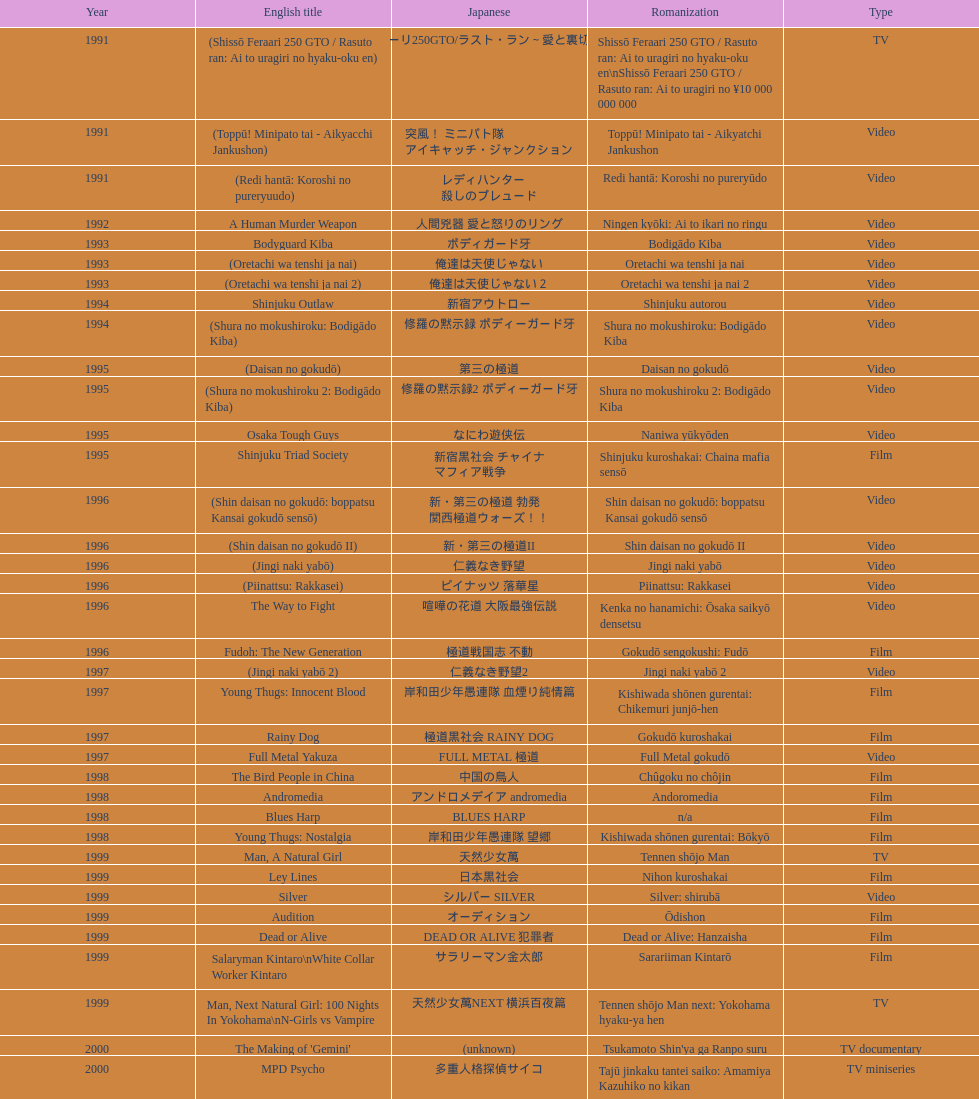State a cinema that was launched earlier than 199 Shinjuku Triad Society. Can you give me this table as a dict? {'header': ['Year', 'English title', 'Japanese', 'Romanization', 'Type'], 'rows': [['1991', '(Shissō Feraari 250 GTO / Rasuto ran: Ai to uragiri no hyaku-oku en)', '疾走フェラーリ250GTO/ラスト・ラン～愛と裏切りの百億円', 'Shissō Feraari 250 GTO / Rasuto ran: Ai to uragiri no hyaku-oku en\\nShissō Feraari 250 GTO / Rasuto ran: Ai to uragiri no ¥10 000 000 000', 'TV'], ['1991', '(Toppū! Minipato tai - Aikyacchi Jankushon)', '突風！ ミニパト隊 アイキャッチ・ジャンクション', 'Toppū! Minipato tai - Aikyatchi Jankushon', 'Video'], ['1991', '(Redi hantā: Koroshi no pureryuudo)', 'レディハンター 殺しのプレュード', 'Redi hantā: Koroshi no pureryūdo', 'Video'], ['1992', 'A Human Murder Weapon', '人間兇器 愛と怒りのリング', 'Ningen kyōki: Ai to ikari no ringu', 'Video'], ['1993', 'Bodyguard Kiba', 'ボディガード牙', 'Bodigādo Kiba', 'Video'], ['1993', '(Oretachi wa tenshi ja nai)', '俺達は天使じゃない', 'Oretachi wa tenshi ja nai', 'Video'], ['1993', '(Oretachi wa tenshi ja nai 2)', '俺達は天使じゃない２', 'Oretachi wa tenshi ja nai 2', 'Video'], ['1994', 'Shinjuku Outlaw', '新宿アウトロー', 'Shinjuku autorou', 'Video'], ['1994', '(Shura no mokushiroku: Bodigādo Kiba)', '修羅の黙示録 ボディーガード牙', 'Shura no mokushiroku: Bodigādo Kiba', 'Video'], ['1995', '(Daisan no gokudō)', '第三の極道', 'Daisan no gokudō', 'Video'], ['1995', '(Shura no mokushiroku 2: Bodigādo Kiba)', '修羅の黙示録2 ボディーガード牙', 'Shura no mokushiroku 2: Bodigādo Kiba', 'Video'], ['1995', 'Osaka Tough Guys', 'なにわ遊侠伝', 'Naniwa yūkyōden', 'Video'], ['1995', 'Shinjuku Triad Society', '新宿黒社会 チャイナ マフィア戦争', 'Shinjuku kuroshakai: Chaina mafia sensō', 'Film'], ['1996', '(Shin daisan no gokudō: boppatsu Kansai gokudō sensō)', '新・第三の極道 勃発 関西極道ウォーズ！！', 'Shin daisan no gokudō: boppatsu Kansai gokudō sensō', 'Video'], ['1996', '(Shin daisan no gokudō II)', '新・第三の極道II', 'Shin daisan no gokudō II', 'Video'], ['1996', '(Jingi naki yabō)', '仁義なき野望', 'Jingi naki yabō', 'Video'], ['1996', '(Piinattsu: Rakkasei)', 'ピイナッツ 落華星', 'Piinattsu: Rakkasei', 'Video'], ['1996', 'The Way to Fight', '喧嘩の花道 大阪最強伝説', 'Kenka no hanamichi: Ōsaka saikyō densetsu', 'Video'], ['1996', 'Fudoh: The New Generation', '極道戦国志 不動', 'Gokudō sengokushi: Fudō', 'Film'], ['1997', '(Jingi naki yabō 2)', '仁義なき野望2', 'Jingi naki yabō 2', 'Video'], ['1997', 'Young Thugs: Innocent Blood', '岸和田少年愚連隊 血煙り純情篇', 'Kishiwada shōnen gurentai: Chikemuri junjō-hen', 'Film'], ['1997', 'Rainy Dog', '極道黒社会 RAINY DOG', 'Gokudō kuroshakai', 'Film'], ['1997', 'Full Metal Yakuza', 'FULL METAL 極道', 'Full Metal gokudō', 'Video'], ['1998', 'The Bird People in China', '中国の鳥人', 'Chûgoku no chôjin', 'Film'], ['1998', 'Andromedia', 'アンドロメデイア andromedia', 'Andoromedia', 'Film'], ['1998', 'Blues Harp', 'BLUES HARP', 'n/a', 'Film'], ['1998', 'Young Thugs: Nostalgia', '岸和田少年愚連隊 望郷', 'Kishiwada shōnen gurentai: Bōkyō', 'Film'], ['1999', 'Man, A Natural Girl', '天然少女萬', 'Tennen shōjo Man', 'TV'], ['1999', 'Ley Lines', '日本黒社会', 'Nihon kuroshakai', 'Film'], ['1999', 'Silver', 'シルバー SILVER', 'Silver: shirubā', 'Video'], ['1999', 'Audition', 'オーディション', 'Ōdishon', 'Film'], ['1999', 'Dead or Alive', 'DEAD OR ALIVE 犯罪者', 'Dead or Alive: Hanzaisha', 'Film'], ['1999', 'Salaryman Kintaro\\nWhite Collar Worker Kintaro', 'サラリーマン金太郎', 'Sarariiman Kintarō', 'Film'], ['1999', 'Man, Next Natural Girl: 100 Nights In Yokohama\\nN-Girls vs Vampire', '天然少女萬NEXT 横浜百夜篇', 'Tennen shōjo Man next: Yokohama hyaku-ya hen', 'TV'], ['2000', "The Making of 'Gemini'", '(unknown)', "Tsukamoto Shin'ya ga Ranpo suru", 'TV documentary'], ['2000', 'MPD Psycho', '多重人格探偵サイコ', 'Tajū jinkaku tantei saiko: Amamiya Kazuhiko no kikan', 'TV miniseries'], ['2000', 'The City of Lost Souls\\nThe City of Strangers\\nThe Hazard City', '漂流街 THE HAZARD CITY', 'Hyōryū-gai', 'Film'], ['2000', 'The Guys from Paradise', '天国から来た男たち', 'Tengoku kara kita otoko-tachi', 'Film'], ['2000', 'Dead or Alive 2: Birds\\nDead or Alive 2: Runaway', 'DEAD OR ALIVE 2 逃亡者', 'Dead or Alive 2: Tōbōsha', 'Film'], ['2001', '(Kikuchi-jō monogatari: sakimori-tachi no uta)', '鞠智城物語 防人たちの唄', 'Kikuchi-jō monogatari: sakimori-tachi no uta', 'Film'], ['2001', '(Zuiketsu gensō: Tonkararin yume densetsu)', '隧穴幻想 トンカラリン夢伝説', 'Zuiketsu gensō: Tonkararin yume densetsu', 'Film'], ['2001', 'Family', 'FAMILY', 'n/a', 'Film'], ['2001', 'Visitor Q', 'ビジターQ', 'Bijitā Q', 'Video'], ['2001', 'Ichi the Killer', '殺し屋1', 'Koroshiya 1', 'Film'], ['2001', 'Agitator', '荒ぶる魂たち', 'Araburu tamashii-tachi', 'Film'], ['2001', 'The Happiness of the Katakuris', 'カタクリ家の幸福', 'Katakuri-ke no kōfuku', 'Film'], ['2002', 'Dead or Alive: Final', 'DEAD OR ALIVE FINAL', 'n/a', 'Film'], ['2002', '(Onna kunishū ikki)', 'おんな 国衆一揆', 'Onna kunishū ikki', '(unknown)'], ['2002', 'Sabu', 'SABU さぶ', 'Sabu', 'TV'], ['2002', 'Graveyard of Honor', '新・仁義の墓場', 'Shin jingi no hakaba', 'Film'], ['2002', 'Shangri-La', '金融破滅ニッポン 桃源郷の人々', "Kin'yū hametsu Nippon: Tōgenkyō no hito-bito", 'Film'], ['2002', 'Pandōra', 'パンドーラ', 'Pandōra', 'Music video'], ['2002', 'Deadly Outlaw: Rekka\\nViolent Fire', '実録・安藤昇侠道（アウトロー）伝 烈火', 'Jitsuroku Andō Noboru kyōdō-den: Rekka', 'Film'], ['2002', 'Pāto-taimu tantei', 'パートタイム探偵', 'Pāto-taimu tantei', 'TV series'], ['2003', 'The Man in White', '許されざる者', 'Yurusarezaru mono', 'Film'], ['2003', 'Gozu', '極道恐怖大劇場 牛頭 GOZU', 'Gokudō kyōfu dai-gekijō: Gozu', 'Film'], ['2003', 'Yakuza Demon', '鬼哭 kikoku', 'Kikoku', 'Video'], ['2003', 'Kōshōnin', '交渉人', 'Kōshōnin', 'TV'], ['2003', "One Missed Call\\nYou've Got a Call", '着信アリ', 'Chakushin Ari', 'Film'], ['2004', 'Zebraman', 'ゼブラーマン', 'Zeburāman', 'Film'], ['2004', 'Pāto-taimu tantei 2', 'パートタイム探偵2', 'Pāto-taimu tantei 2', 'TV'], ['2004', 'Box segment in Three... Extremes', 'BOX（『美しい夜、残酷な朝』）', 'Saam gaang yi', 'Segment in feature film'], ['2004', 'Izo', 'IZO', 'IZO', 'Film'], ['2005', 'Ultraman Max', 'ウルトラマンマックス', 'Urutoraman Makkusu', 'Episodes 15 and 16 from TV tokusatsu series'], ['2005', 'The Great Yokai War', '妖怪大戦争', 'Yokai Daisenso', 'Film'], ['2006', 'Big Bang Love, Juvenile A\\n4.6 Billion Years of Love', '46億年の恋', '46-okunen no koi', 'Film'], ['2006', 'Waru', 'WARU', 'Waru', 'Film'], ['2006', 'Imprint episode from Masters of Horror', 'インプリント ～ぼっけえ、きょうてえ～', 'Inpurinto ~bokke kyote~', 'TV episode'], ['2006', 'Waru: kanketsu-hen', '', 'Waru: kanketsu-hen', 'Video'], ['2006', 'Sun Scarred', '太陽の傷', 'Taiyo no kizu', 'Film'], ['2007', 'Sukiyaki Western Django', 'スキヤキ・ウエスタン ジャンゴ', 'Sukiyaki wesutān jango', 'Film'], ['2007', 'Crows Zero', 'クローズZERO', 'Kurōzu Zero', 'Film'], ['2007', 'Like a Dragon', '龍が如く 劇場版', 'Ryu ga Gotoku Gekijōban', 'Film'], ['2007', 'Zatoichi', '座頭市', 'Zatōichi', 'Stageplay'], ['2007', 'Detective Story', '探偵物語', 'Tantei monogatari', 'Film'], ['2008', "God's Puzzle", '神様のパズル', 'Kamisama no pazuru', 'Film'], ['2008', 'K-tai Investigator 7', 'ケータイ捜査官7', 'Keitai Sōsakan 7', 'TV'], ['2009', 'Yatterman', 'ヤッターマン', 'Yattaaman', 'Film'], ['2009', 'Crows Zero 2', 'クローズZERO 2', 'Kurōzu Zero 2', 'Film'], ['2010', 'Thirteen Assassins', '十三人の刺客', 'Jûsan-nin no shikaku', 'Film'], ['2010', 'Zebraman 2: Attack on Zebra City', 'ゼブラーマン -ゼブラシティの逆襲', 'Zeburāman -Zebura Shiti no Gyakushū', 'Film'], ['2011', 'Ninja Kids!!!', '忍たま乱太郎', 'Nintama Rantarō', 'Film'], ['2011', 'Hara-Kiri: Death of a Samurai', '一命', 'Ichimei', 'Film'], ['2012', 'Ace Attorney', '逆転裁判', 'Gyakuten Saiban', 'Film'], ['2012', "For Love's Sake", '愛と誠', 'Ai to makoto', 'Film'], ['2012', 'Lesson of the Evil', '悪の教典', 'Aku no Kyōten', 'Film'], ['2013', 'Shield of Straw', '藁の楯', 'Wara no Tate', 'Film'], ['2013', 'The Mole Song: Undercover Agent Reiji', '土竜の唄\u3000潜入捜査官 REIJI', 'Mogura no uta – sennyu sosakan: Reiji', 'Film']]} 